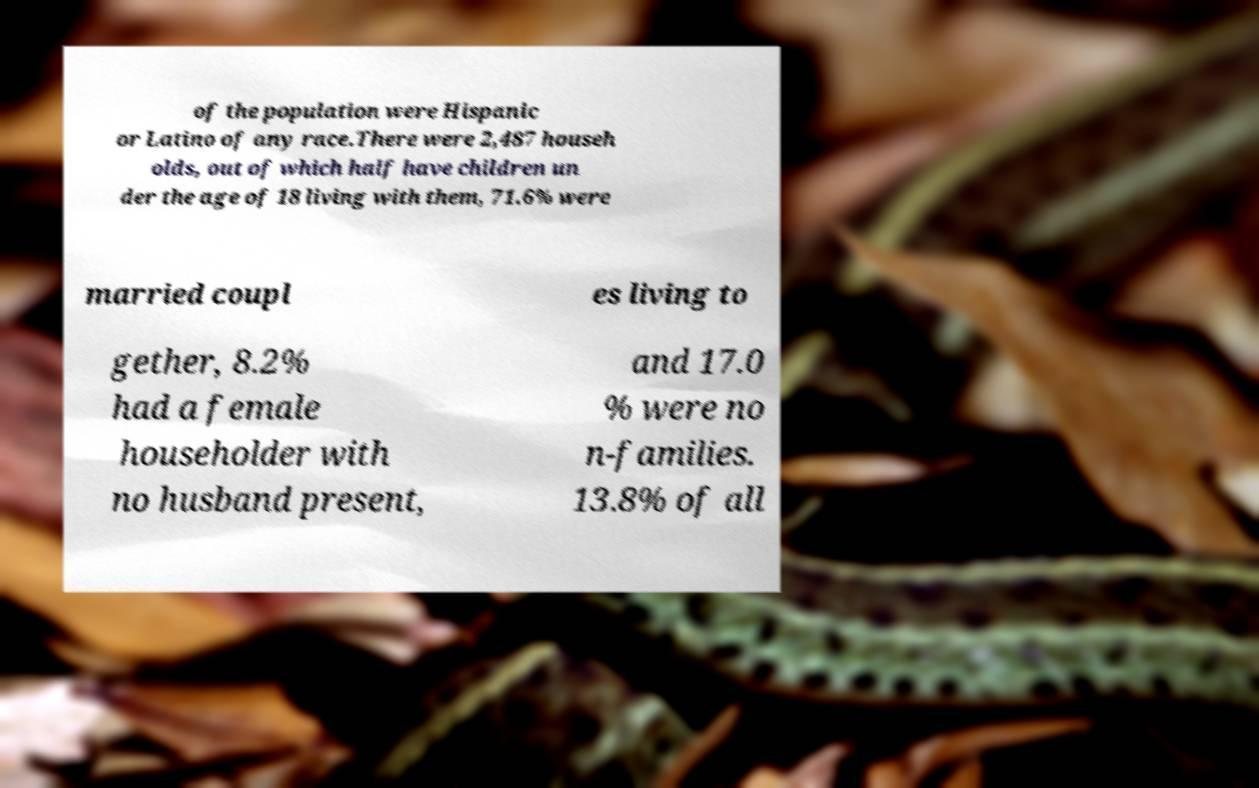There's text embedded in this image that I need extracted. Can you transcribe it verbatim? of the population were Hispanic or Latino of any race.There were 2,487 househ olds, out of which half have children un der the age of 18 living with them, 71.6% were married coupl es living to gether, 8.2% had a female householder with no husband present, and 17.0 % were no n-families. 13.8% of all 